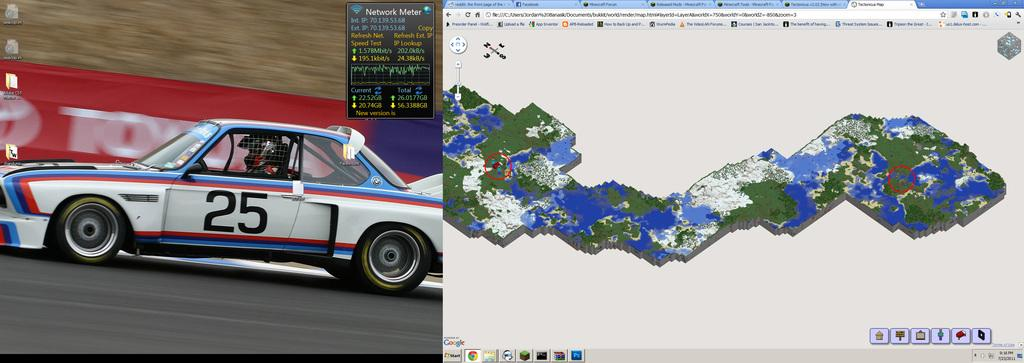What type of content is shown in the image? The image contains screenshots. What is depicted in the screenshots? The screenshots contain a sports car and an aerial view. What type of burst can be seen in the image? There is no burst present in the image; it contains screenshots of a sports car and an aerial view. 